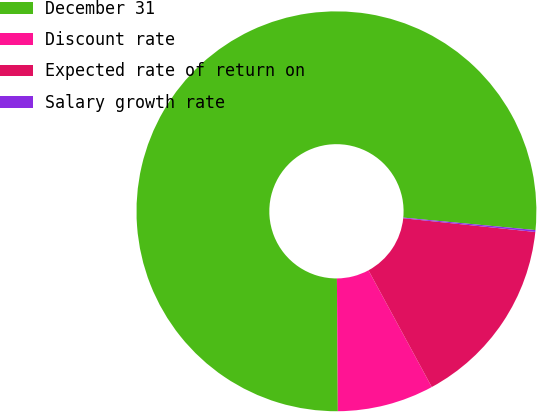Convert chart. <chart><loc_0><loc_0><loc_500><loc_500><pie_chart><fcel>December 31<fcel>Discount rate<fcel>Expected rate of return on<fcel>Salary growth rate<nl><fcel>76.61%<fcel>7.8%<fcel>15.44%<fcel>0.15%<nl></chart> 